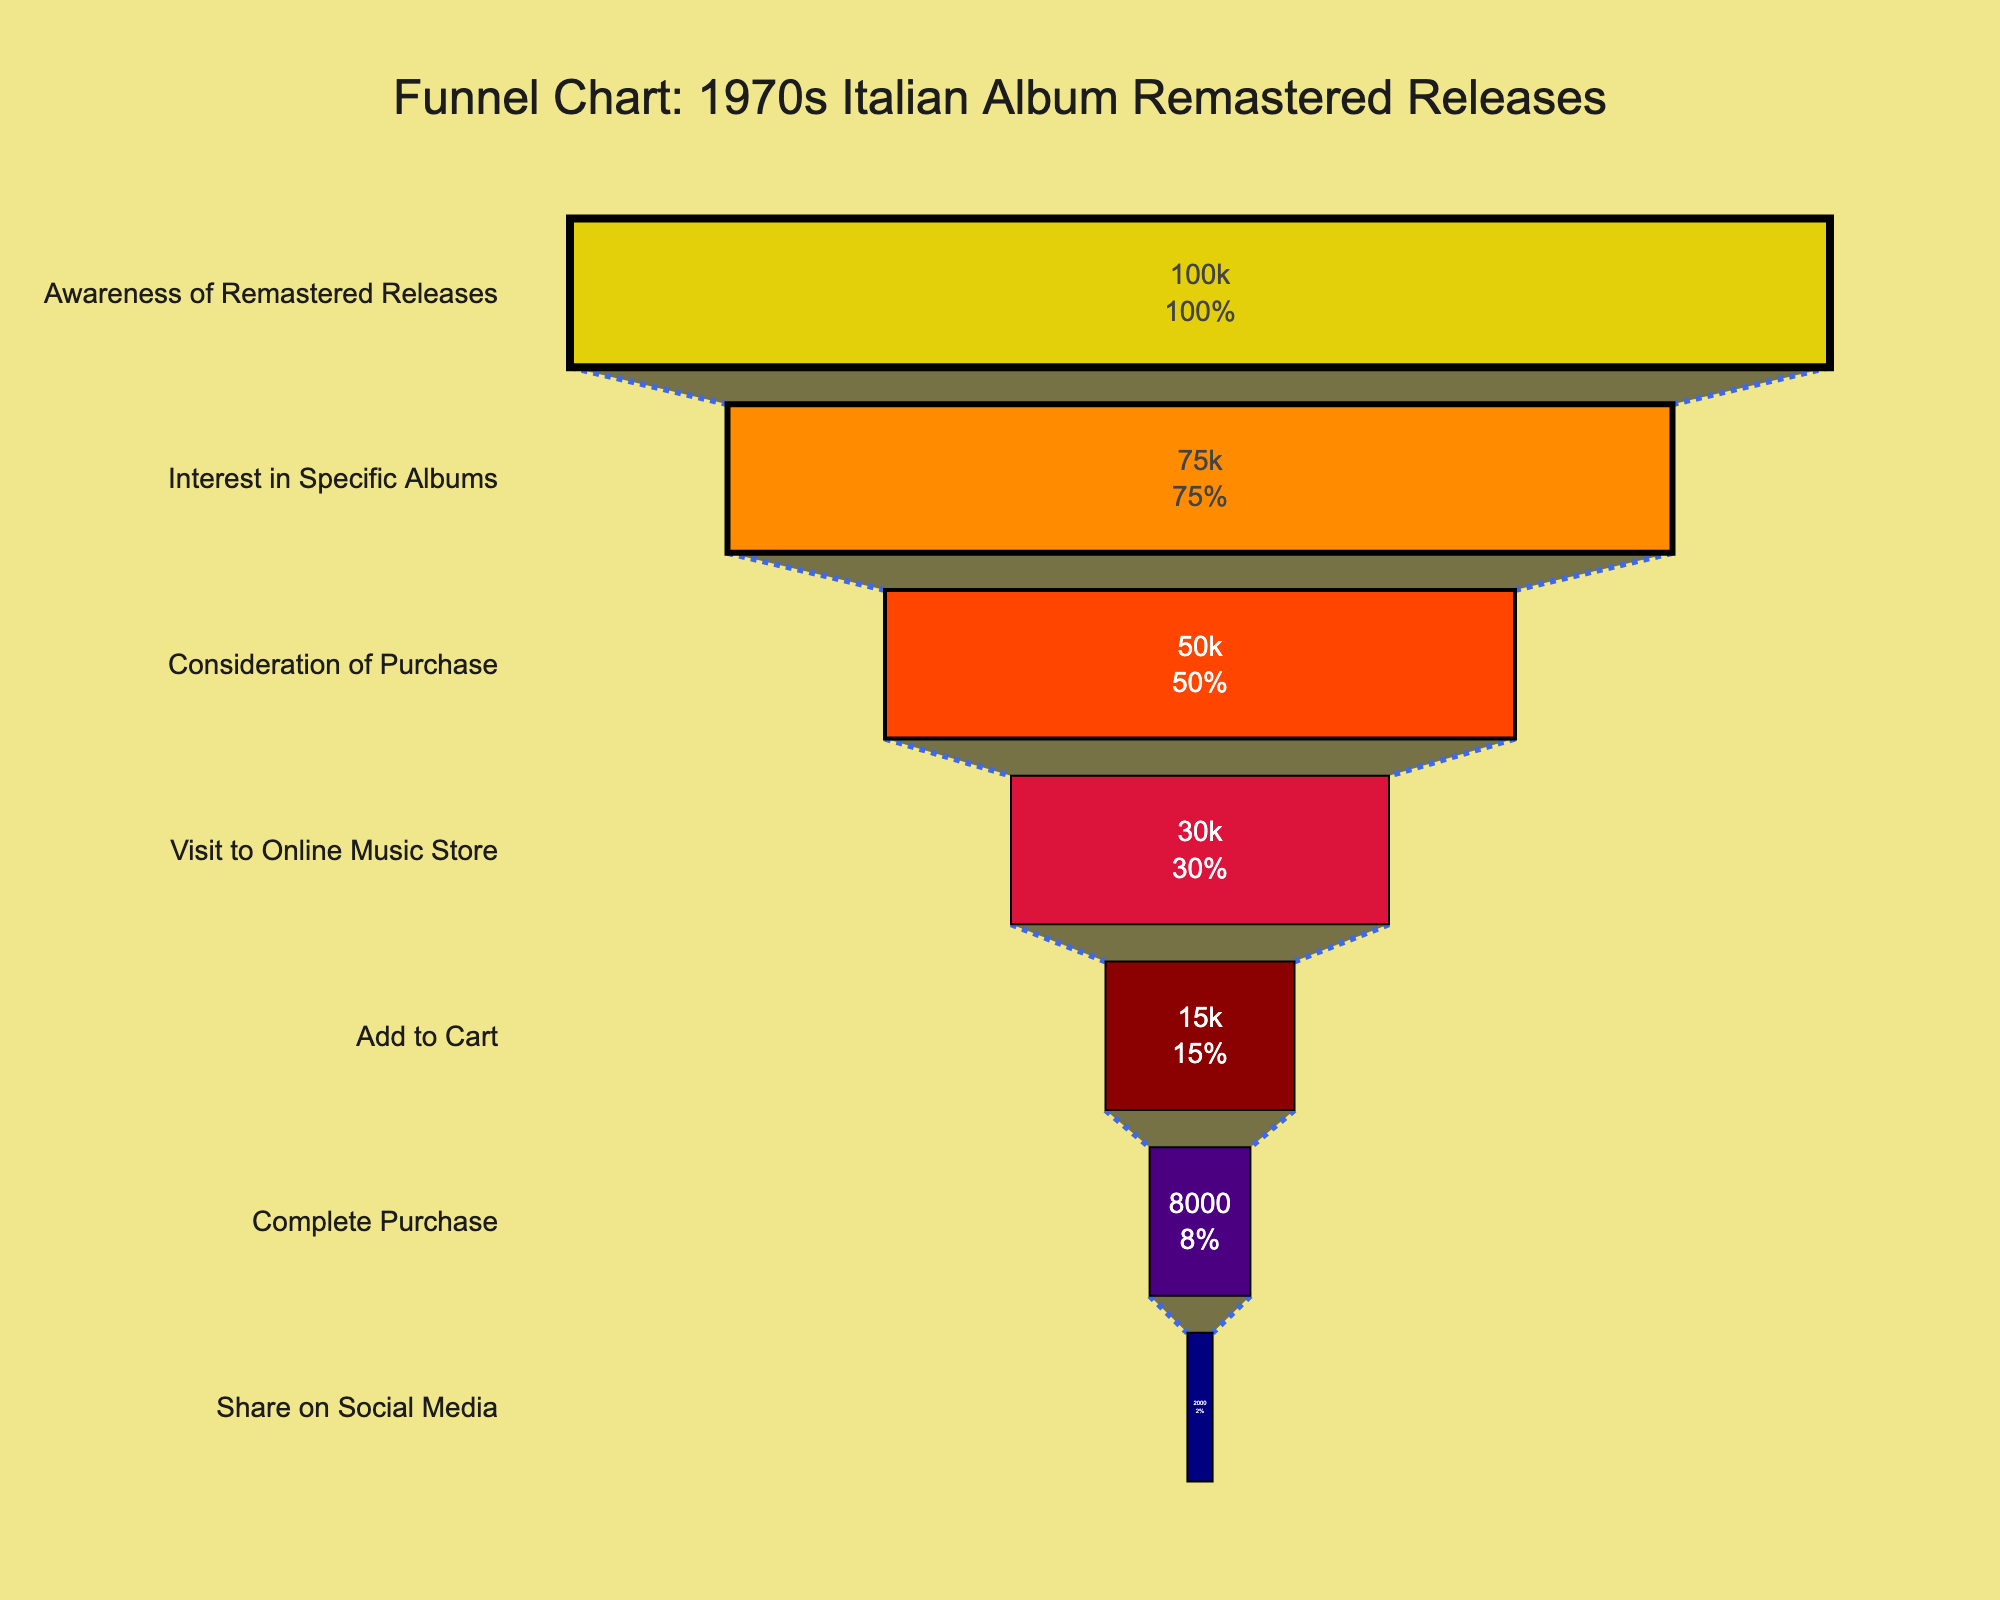What is the title of the funnel chart? The title is written at the top of the funnel chart and usually summarizes the main focus of the chart. The title for this chart is quite descriptive.
Answer: Funnel Chart: 1970s Italian Album Remastered Releases What color represents the "Add to Cart" stage? The colors of the stages are indicated within the funnel shapes. Each stage has its unique color for easy differentiation. The "Add to Cart" stage is represented by the fifth shape from the top.
Answer: Dark Red How many people reach the "Complete Purchase" stage? The number of people is shown inside each stage of the funnel. The "Complete Purchase" stage is the second to last shape from the top.
Answer: 8000 What percentage of people who visit the online music store actually complete the purchase? To find the percentage, divide the number of people who complete the purchase by the number of people who visit the online music store and then multiply by 100. 8000/30000 * 100 = 26.67%
Answer: 26.67% By how many people does the number of people decrease between the "Interest in Specific Albums" stage and the "Visit to Online Music Store" stage? To get the decrease, subtract the number of people at the "Visit to Online Music Store" stage from those at the "Interest in Specific Albums" stage. 75000 - 30000 = 45000
Answer: 45000 Which stage has the lowest number of people? The funnel chart is sorted from the highest to the lowest number of people by default. The lowest number of people would be at the bottom of the funnel.
Answer: Share on Social Media What is the total decrease in the number of people from "Awareness of Remastered Releases" to "Complete Purchase"? Subtract the number of people at the "Complete Purchase" stage from those at the "Awareness of Remastered Releases" stage. 100000 - 8000 = 92000
Answer: 92000 What is the relative percentage decrease in the number of people from "Awareness of Remastered Releases" to "Interest in Specific Albums"? Calculate the difference between the two stages and then find the percentage of this difference with respect to the "Awareness of Remastered Releases" stage. 100000 - 75000 = 25000. (25000 / 100000) * 100 = 25%
Answer: 25% How many people share the albums on social media as a percentage of those who add the album to their cart? Divide the number of people who share on social media by the number who added to cart and then multiply by 100. 2000 / 15000 * 100 = 13.33%
Answer: 13.33% By what percentage do the "Consideration of Purchase" and the "Visit to Online Music Store" stages differ? Compute the absolute difference between the two stages and then find the percentage difference with respect to the "Consideration of Purchase" stage. 50000 - 30000 = 20000. (20000 / 50000) * 100 = 40%
Answer: 40% 